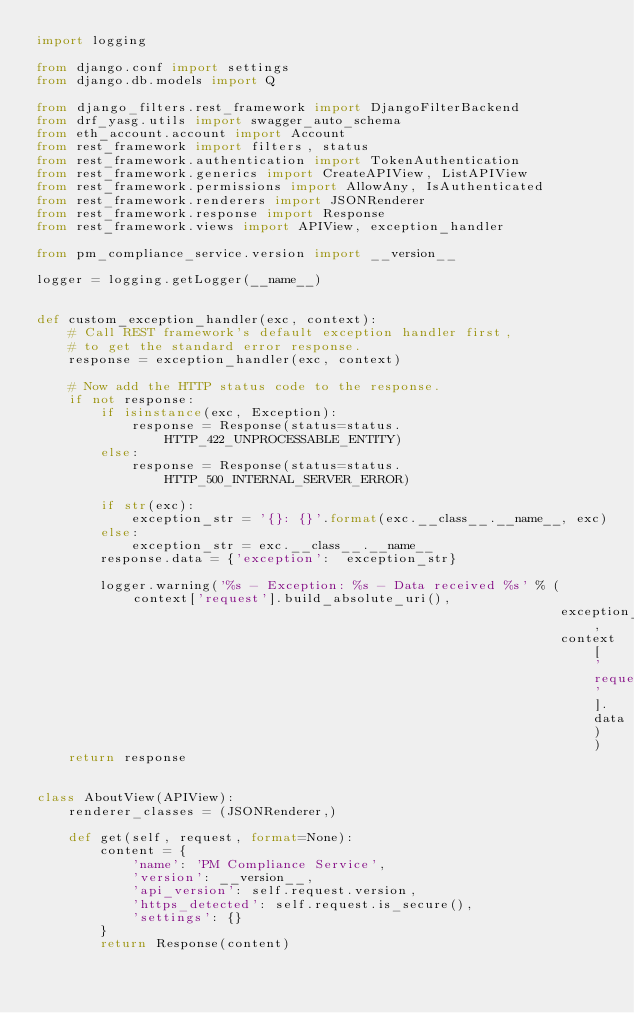Convert code to text. <code><loc_0><loc_0><loc_500><loc_500><_Python_>import logging

from django.conf import settings
from django.db.models import Q

from django_filters.rest_framework import DjangoFilterBackend
from drf_yasg.utils import swagger_auto_schema
from eth_account.account import Account
from rest_framework import filters, status
from rest_framework.authentication import TokenAuthentication
from rest_framework.generics import CreateAPIView, ListAPIView
from rest_framework.permissions import AllowAny, IsAuthenticated
from rest_framework.renderers import JSONRenderer
from rest_framework.response import Response
from rest_framework.views import APIView, exception_handler

from pm_compliance_service.version import __version__

logger = logging.getLogger(__name__)


def custom_exception_handler(exc, context):
    # Call REST framework's default exception handler first,
    # to get the standard error response.
    response = exception_handler(exc, context)

    # Now add the HTTP status code to the response.
    if not response:
        if isinstance(exc, Exception):
            response = Response(status=status.HTTP_422_UNPROCESSABLE_ENTITY)
        else:
            response = Response(status=status.HTTP_500_INTERNAL_SERVER_ERROR)

        if str(exc):
            exception_str = '{}: {}'.format(exc.__class__.__name__, exc)
        else:
            exception_str = exc.__class__.__name__
        response.data = {'exception':  exception_str}

        logger.warning('%s - Exception: %s - Data received %s' % (context['request'].build_absolute_uri(),
                                                                  exception_str,
                                                                  context['request'].data))
    return response


class AboutView(APIView):
    renderer_classes = (JSONRenderer,)

    def get(self, request, format=None):
        content = {
            'name': 'PM Compliance Service',
            'version': __version__,
            'api_version': self.request.version,
            'https_detected': self.request.is_secure(),
            'settings': {}
        }
        return Response(content)
</code> 